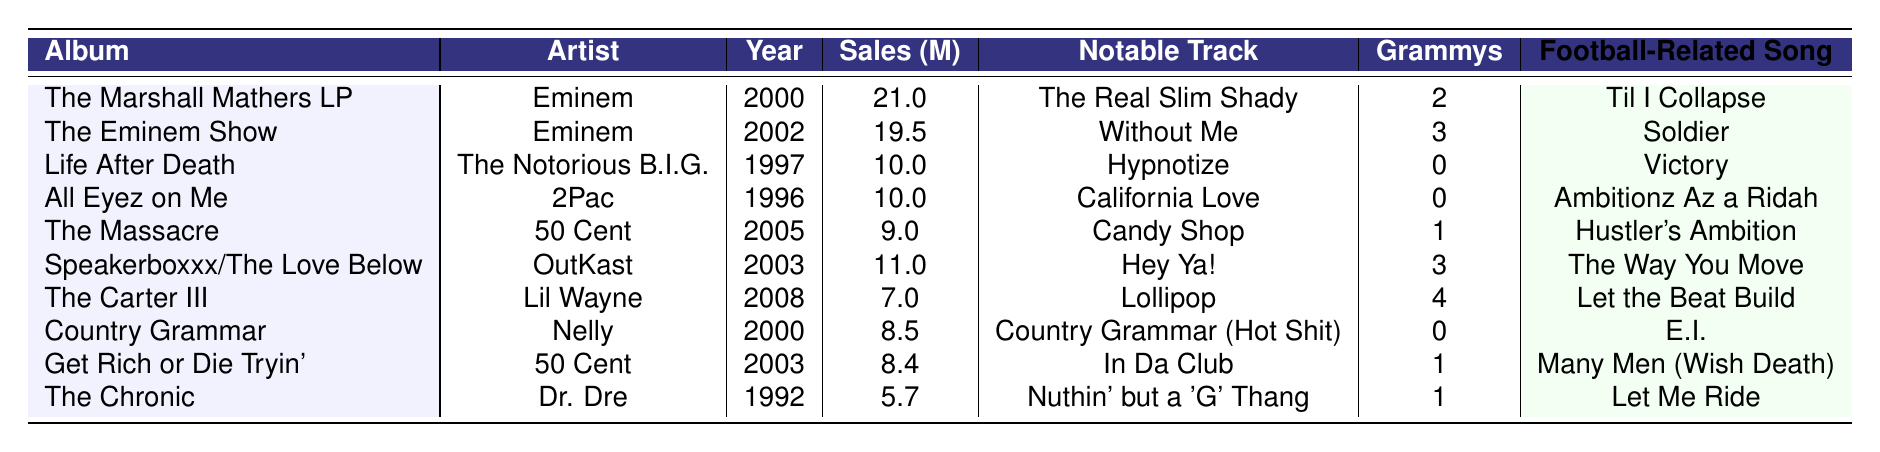What is the best-selling hip-hop album of all time? The best-selling hip-hop album is "The Marshall Mathers LP" by Eminem, with sales of 21.0 million copies.
Answer: The Marshall Mathers LP How many Grammy Awards did "The Eminem Show" win? "The Eminem Show" won 3 Grammy Awards, as stated in the Grammy Awards column.
Answer: 3 Which artist has the most albums in the top 10 list? Eminem appears twice in the top 10 list with "The Marshall Mathers LP" and "The Eminem Show," which means he has the most albums.
Answer: Eminem What is the total sales of all albums by Dr. Dre on this list? Dr. Dre's only album on the list, "The Chronic," has sales of 5.7 million. So the total sales for Dr. Dre is simply 5.7 million.
Answer: 5.7 million Which notable track is associated with "Life After Death"? The notable track associated with "Life After Death" is "Hypnotize," which is specified in the table.
Answer: Hypnotize Is there any album by 50 Cent that won 3 Grammy Awards? No, the album "The Massacre" by 50 Cent only won 1 Grammy Award, and "Get Rich or Die Tryin'" won 1 as well.
Answer: No What is the difference in sales between "The Eminem Show" and "The Carter III"? "The Eminem Show" has 19.5 million in sales and "The Carter III" has 7.0 million. The difference is 19.5 - 7.0 = 12.5 million.
Answer: 12.5 million How many total Grammy Awards have the artists in this top 10 list won? The total number of Grammy Awards can be calculated by adding each album's Grammy Awards: 2 + 3 + 0 + 0 + 1 + 3 + 4 + 0 + 1 + 1 = 15.
Answer: 15 What is the average sales of albums by Eminem? Eminem has two albums: "The Marshall Mathers LP" (21.0 million) and "The Eminem Show" (19.5 million). The average is (21.0 + 19.5) / 2 = 20.25 million.
Answer: 20.25 million Which album from the list was released latest? The album released latest is "The Carter III" by Lil Wayne, which was released in 2008.
Answer: The Carter III 